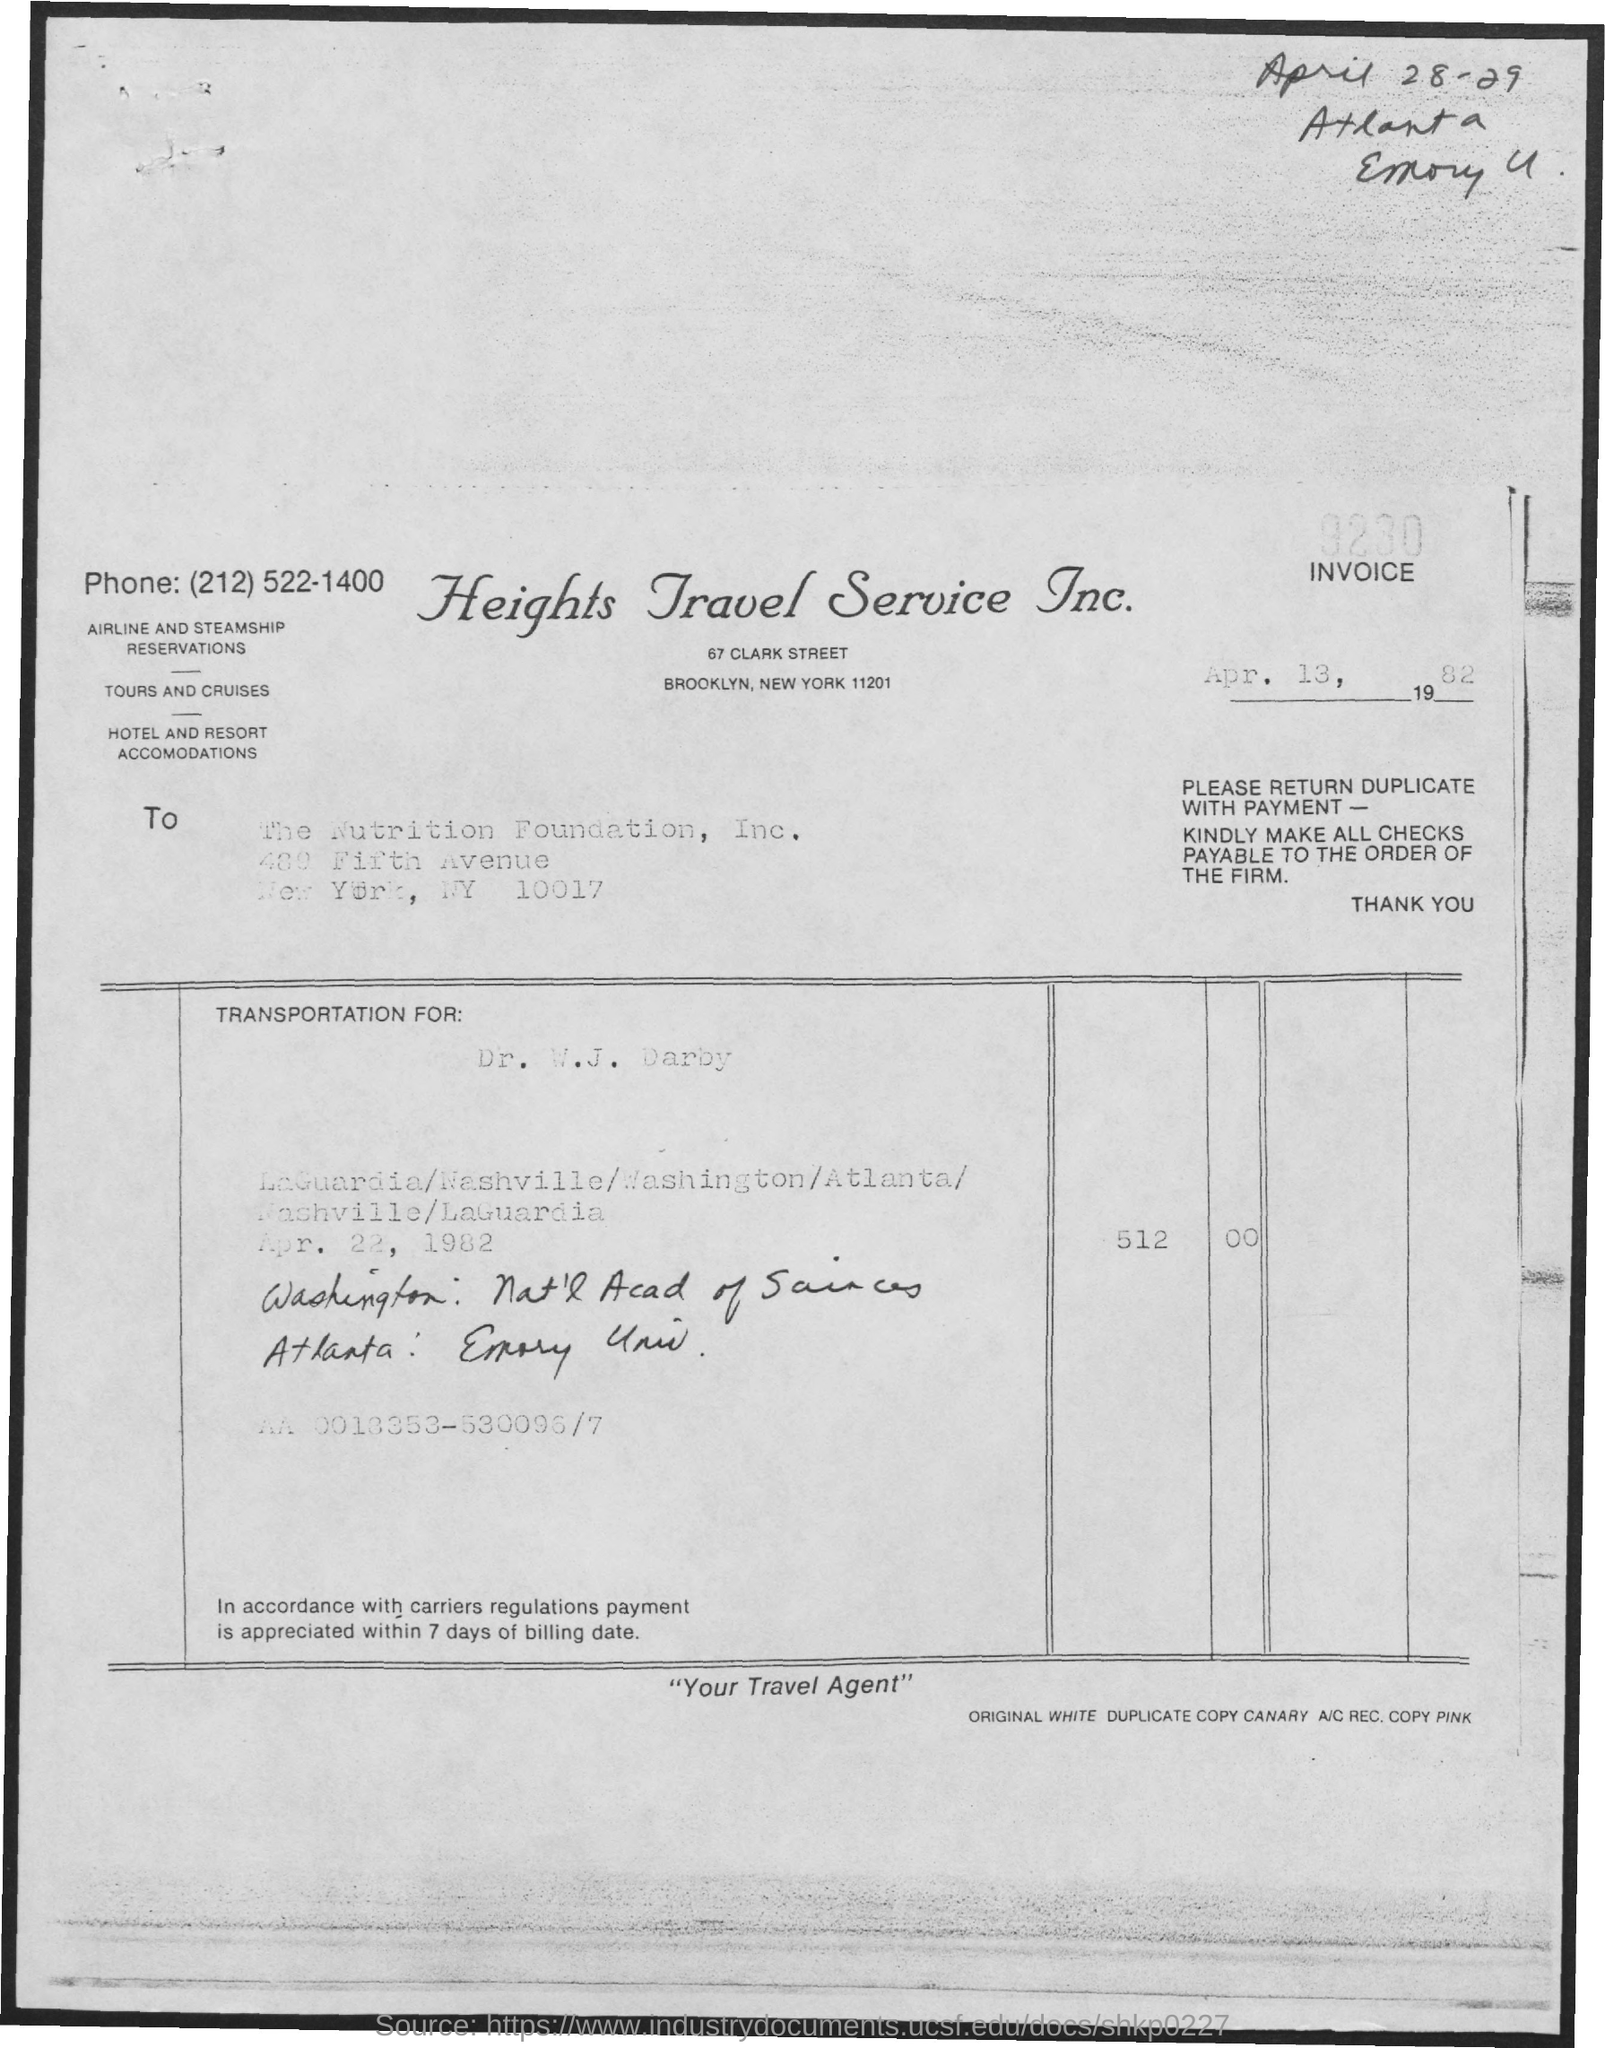What is the Invoice Number?
Give a very brief answer. 9280. What is the date below the invoice number?
Your answer should be compact. Apr. 13, 1982. What is the date at the top right of the document?
Provide a succinct answer. April 28-29. 